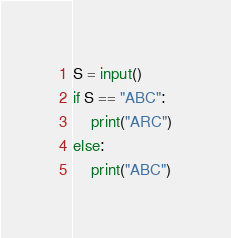<code> <loc_0><loc_0><loc_500><loc_500><_Python_>S = input()
if S == "ABC":
    print("ARC")
else:
    print("ABC")
</code> 